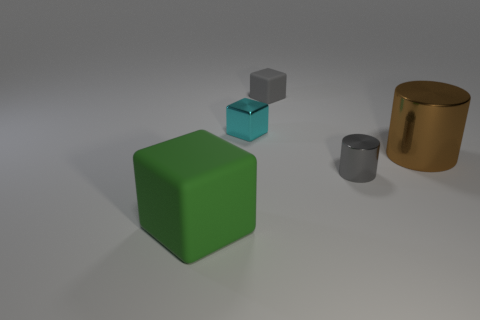How many objects are either cubes right of the big cube or gray cylinders?
Ensure brevity in your answer.  3. What material is the cyan object that is the same size as the gray matte cube?
Ensure brevity in your answer.  Metal. What is the color of the small block to the left of the matte cube that is right of the big green block?
Your response must be concise. Cyan. How many big objects are behind the large green rubber thing?
Your answer should be very brief. 1. The tiny cylinder is what color?
Your answer should be very brief. Gray. What number of big objects are either green cubes or brown cylinders?
Your answer should be very brief. 2. There is a small metallic thing that is in front of the brown thing; does it have the same color as the shiny cylinder that is behind the gray cylinder?
Keep it short and to the point. No. What number of other things are the same color as the tiny shiny cylinder?
Offer a very short reply. 1. There is a metallic thing that is behind the brown metallic object; what is its shape?
Your answer should be very brief. Cube. Is the number of big green rubber cylinders less than the number of brown shiny objects?
Your answer should be very brief. Yes. 